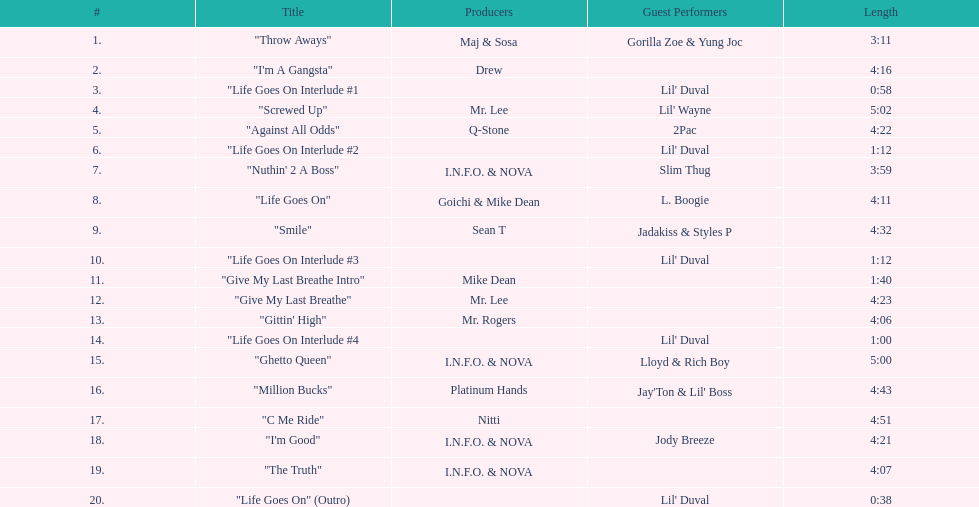What is the number of tracks featuring 2pac? 1. 